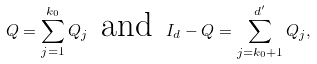Convert formula to latex. <formula><loc_0><loc_0><loc_500><loc_500>Q = \sum _ { j = 1 } ^ { k _ { 0 } } Q _ { j } \, \text { and } \, I _ { d } - Q = \sum _ { j = k _ { 0 } + 1 } ^ { d ^ { \prime } } Q _ { j } ,</formula> 